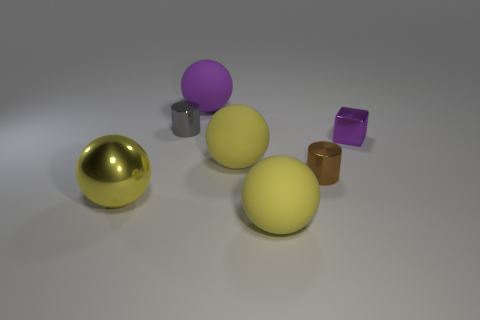Subtract all cyan cylinders. How many yellow spheres are left? 3 Subtract all brown cylinders. Subtract all green blocks. How many cylinders are left? 1 Add 2 tiny red balls. How many objects exist? 9 Subtract all blocks. How many objects are left? 6 Add 2 large purple spheres. How many large purple spheres are left? 3 Add 5 tiny objects. How many tiny objects exist? 8 Subtract 1 gray cylinders. How many objects are left? 6 Subtract all purple blocks. Subtract all small gray cylinders. How many objects are left? 5 